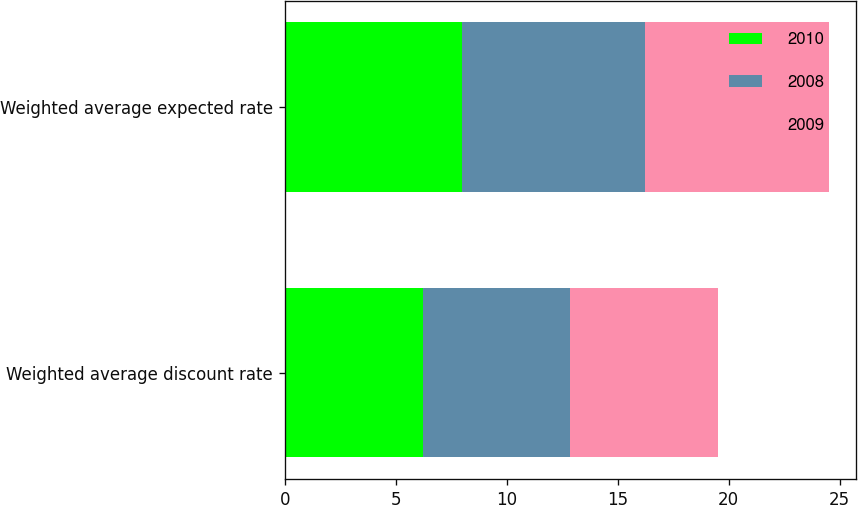Convert chart to OTSL. <chart><loc_0><loc_0><loc_500><loc_500><stacked_bar_chart><ecel><fcel>Weighted average discount rate<fcel>Weighted average expected rate<nl><fcel>2010<fcel>6.25<fcel>8<nl><fcel>2008<fcel>6.6<fcel>8.25<nl><fcel>2009<fcel>6.65<fcel>8.25<nl></chart> 